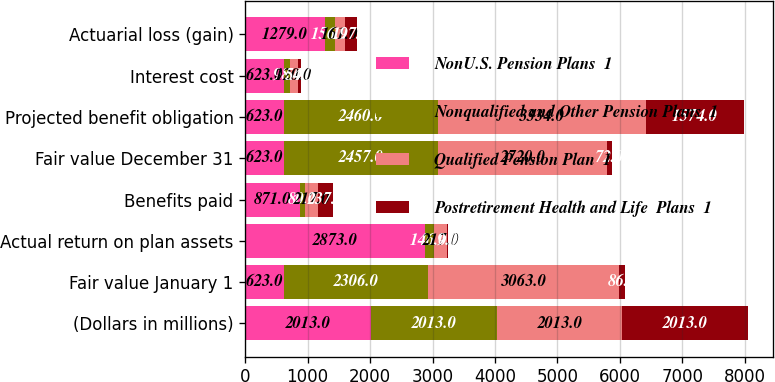Convert chart to OTSL. <chart><loc_0><loc_0><loc_500><loc_500><stacked_bar_chart><ecel><fcel>(Dollars in millions)<fcel>Fair value January 1<fcel>Actual return on plan assets<fcel>Benefits paid<fcel>Fair value December 31<fcel>Projected benefit obligation<fcel>Interest cost<fcel>Actuarial loss (gain)<nl><fcel>NonU.S. Pension Plans  1<fcel>2013<fcel>623<fcel>2873<fcel>871<fcel>623<fcel>623<fcel>623<fcel>1279<nl><fcel>Nonqualified and Other Pension Plans  1<fcel>2013<fcel>2306<fcel>146<fcel>80<fcel>2457<fcel>2460<fcel>98<fcel>156<nl><fcel>Qualified Pension Plan  1<fcel>2013<fcel>3063<fcel>217<fcel>217<fcel>2720<fcel>3334<fcel>120<fcel>161<nl><fcel>Postretirement Health and Life  Plans  1<fcel>2013<fcel>86<fcel>9<fcel>237<fcel>72<fcel>1574<fcel>54<fcel>197<nl></chart> 